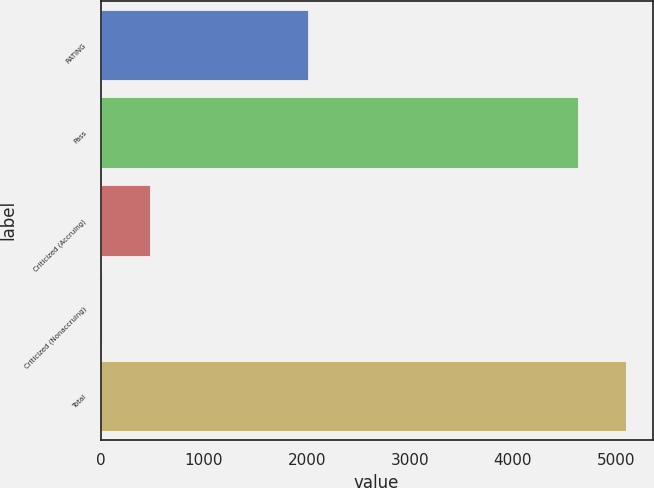Convert chart to OTSL. <chart><loc_0><loc_0><loc_500><loc_500><bar_chart><fcel>RATING<fcel>Pass<fcel>Criticized (Accruing)<fcel>Criticized (Nonaccruing)<fcel>Total<nl><fcel>2016<fcel>4632<fcel>475.7<fcel>8<fcel>5099.7<nl></chart> 